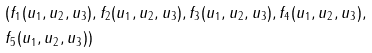<formula> <loc_0><loc_0><loc_500><loc_500>& ( f _ { 1 } ( u _ { 1 } , u _ { 2 } , u _ { 3 } ) , f _ { 2 } ( u _ { 1 } , u _ { 2 } , u _ { 3 } ) , f _ { 3 } ( u _ { 1 } , u _ { 2 } , u _ { 3 } ) , f _ { 4 } ( u _ { 1 } , u _ { 2 } , u _ { 3 } ) , \\ & f _ { 5 } ( u _ { 1 } , u _ { 2 } , u _ { 3 } ) )</formula> 